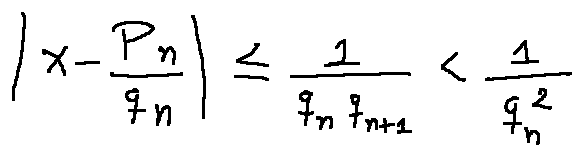Convert formula to latex. <formula><loc_0><loc_0><loc_500><loc_500>| x - \frac { p _ { n } } { q _ { n } } | \leq \frac { 1 } { q _ { n } q _ { n + 1 } } < \frac { 1 } { q _ { n } ^ { 2 } }</formula> 